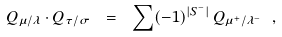<formula> <loc_0><loc_0><loc_500><loc_500>Q _ { \mu / \lambda } \cdot Q _ { \tau / \sigma } \ = \ \sum ( - 1 ) ^ { | S ^ { - } | } \, Q _ { \mu ^ { + } / \lambda ^ { - } } \ ,</formula> 